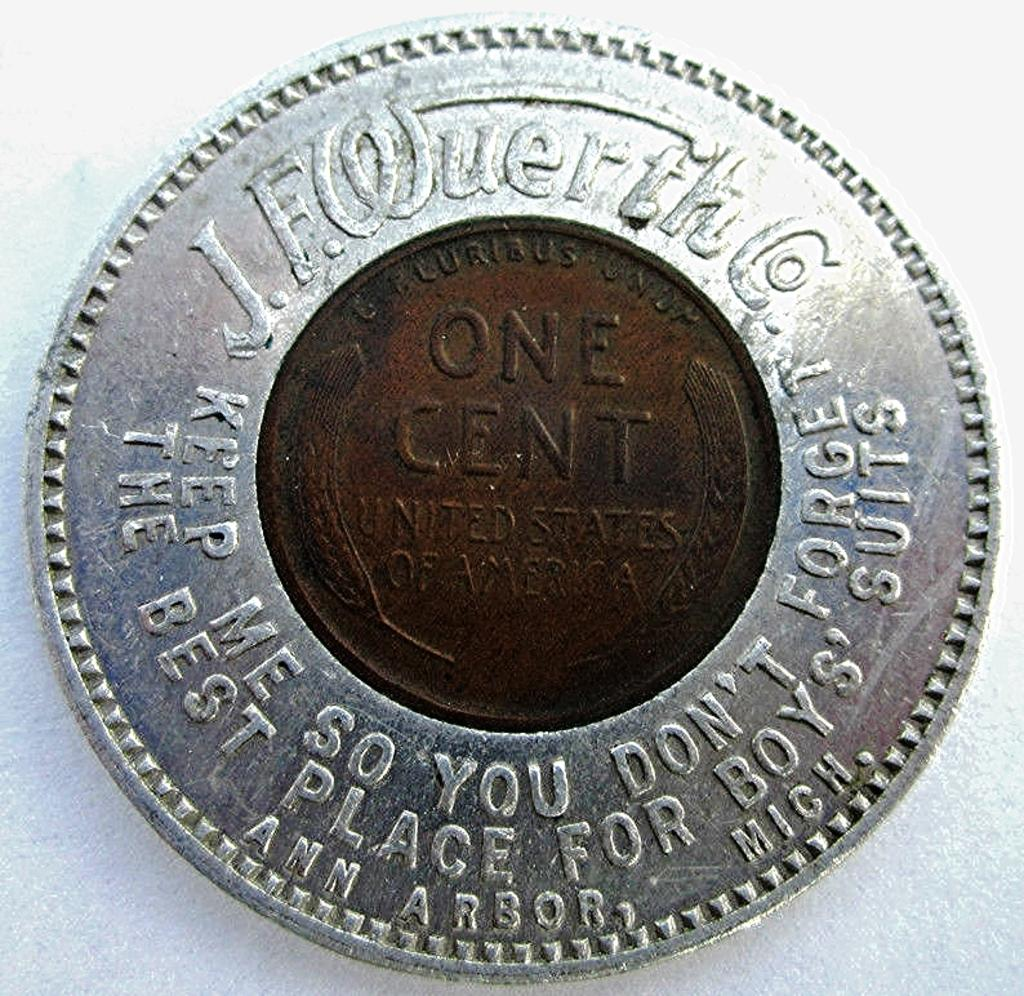<image>
Relay a brief, clear account of the picture shown. An old one cent coin made in Ann Arbor, Mich, United States. 